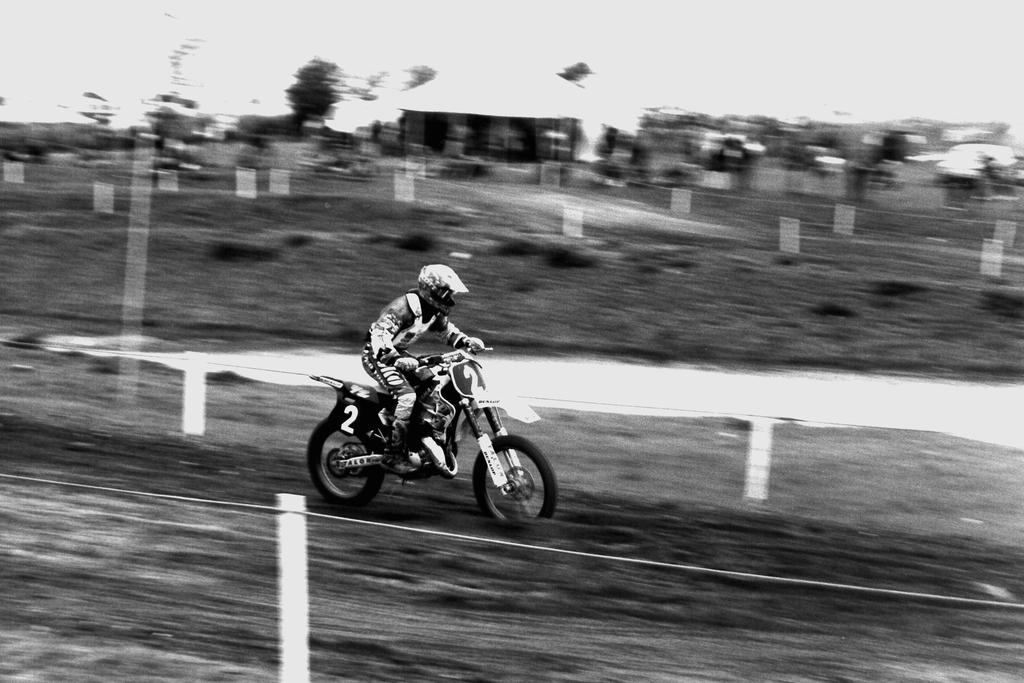What is the main subject of the image? There is a person in the image. What is the person doing in the image? The person is riding a bike. Can you describe the background of the image? The background of the image is blurred. What type of behavior can be observed in the cobweb present in the image? There is no cobweb present in the image. How does the person's action affect the earth in the image? There is no indication of the earth in the image, and the person's action does not affect it. 